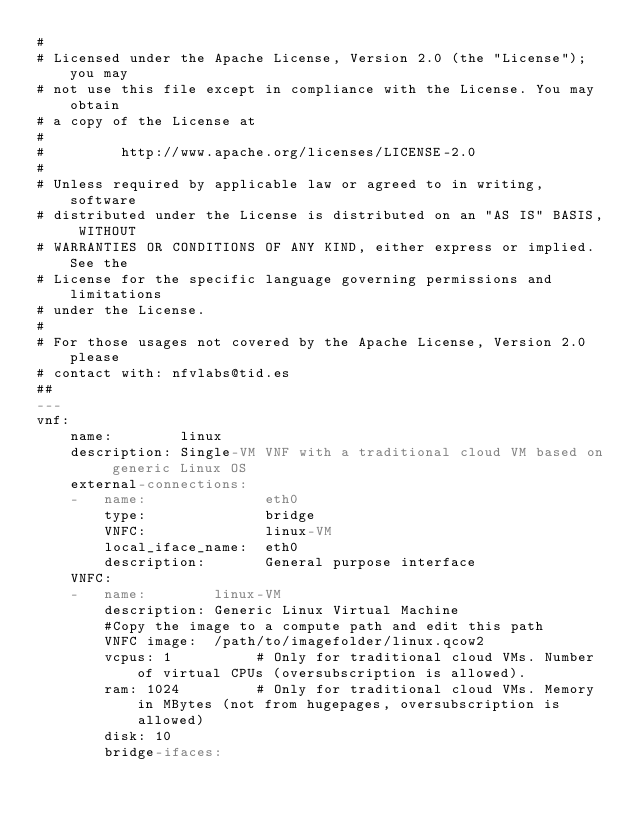<code> <loc_0><loc_0><loc_500><loc_500><_YAML_>#
# Licensed under the Apache License, Version 2.0 (the "License"); you may
# not use this file except in compliance with the License. You may obtain
# a copy of the License at
#
#         http://www.apache.org/licenses/LICENSE-2.0
#
# Unless required by applicable law or agreed to in writing, software
# distributed under the License is distributed on an "AS IS" BASIS, WITHOUT
# WARRANTIES OR CONDITIONS OF ANY KIND, either express or implied. See the
# License for the specific language governing permissions and limitations
# under the License.
#
# For those usages not covered by the Apache License, Version 2.0 please
# contact with: nfvlabs@tid.es
##
---
vnf:
    name:        linux
    description: Single-VM VNF with a traditional cloud VM based on generic Linux OS
    external-connections:
    -   name:              eth0
        type:              bridge
        VNFC:              linux-VM
        local_iface_name:  eth0
        description:       General purpose interface
    VNFC:
    -   name:        linux-VM
        description: Generic Linux Virtual Machine
        #Copy the image to a compute path and edit this path
        VNFC image:  /path/to/imagefolder/linux.qcow2
        vcpus: 1          # Only for traditional cloud VMs. Number of virtual CPUs (oversubscription is allowed).
        ram: 1024         # Only for traditional cloud VMs. Memory in MBytes (not from hugepages, oversubscription is allowed)
        disk: 10
        bridge-ifaces:</code> 